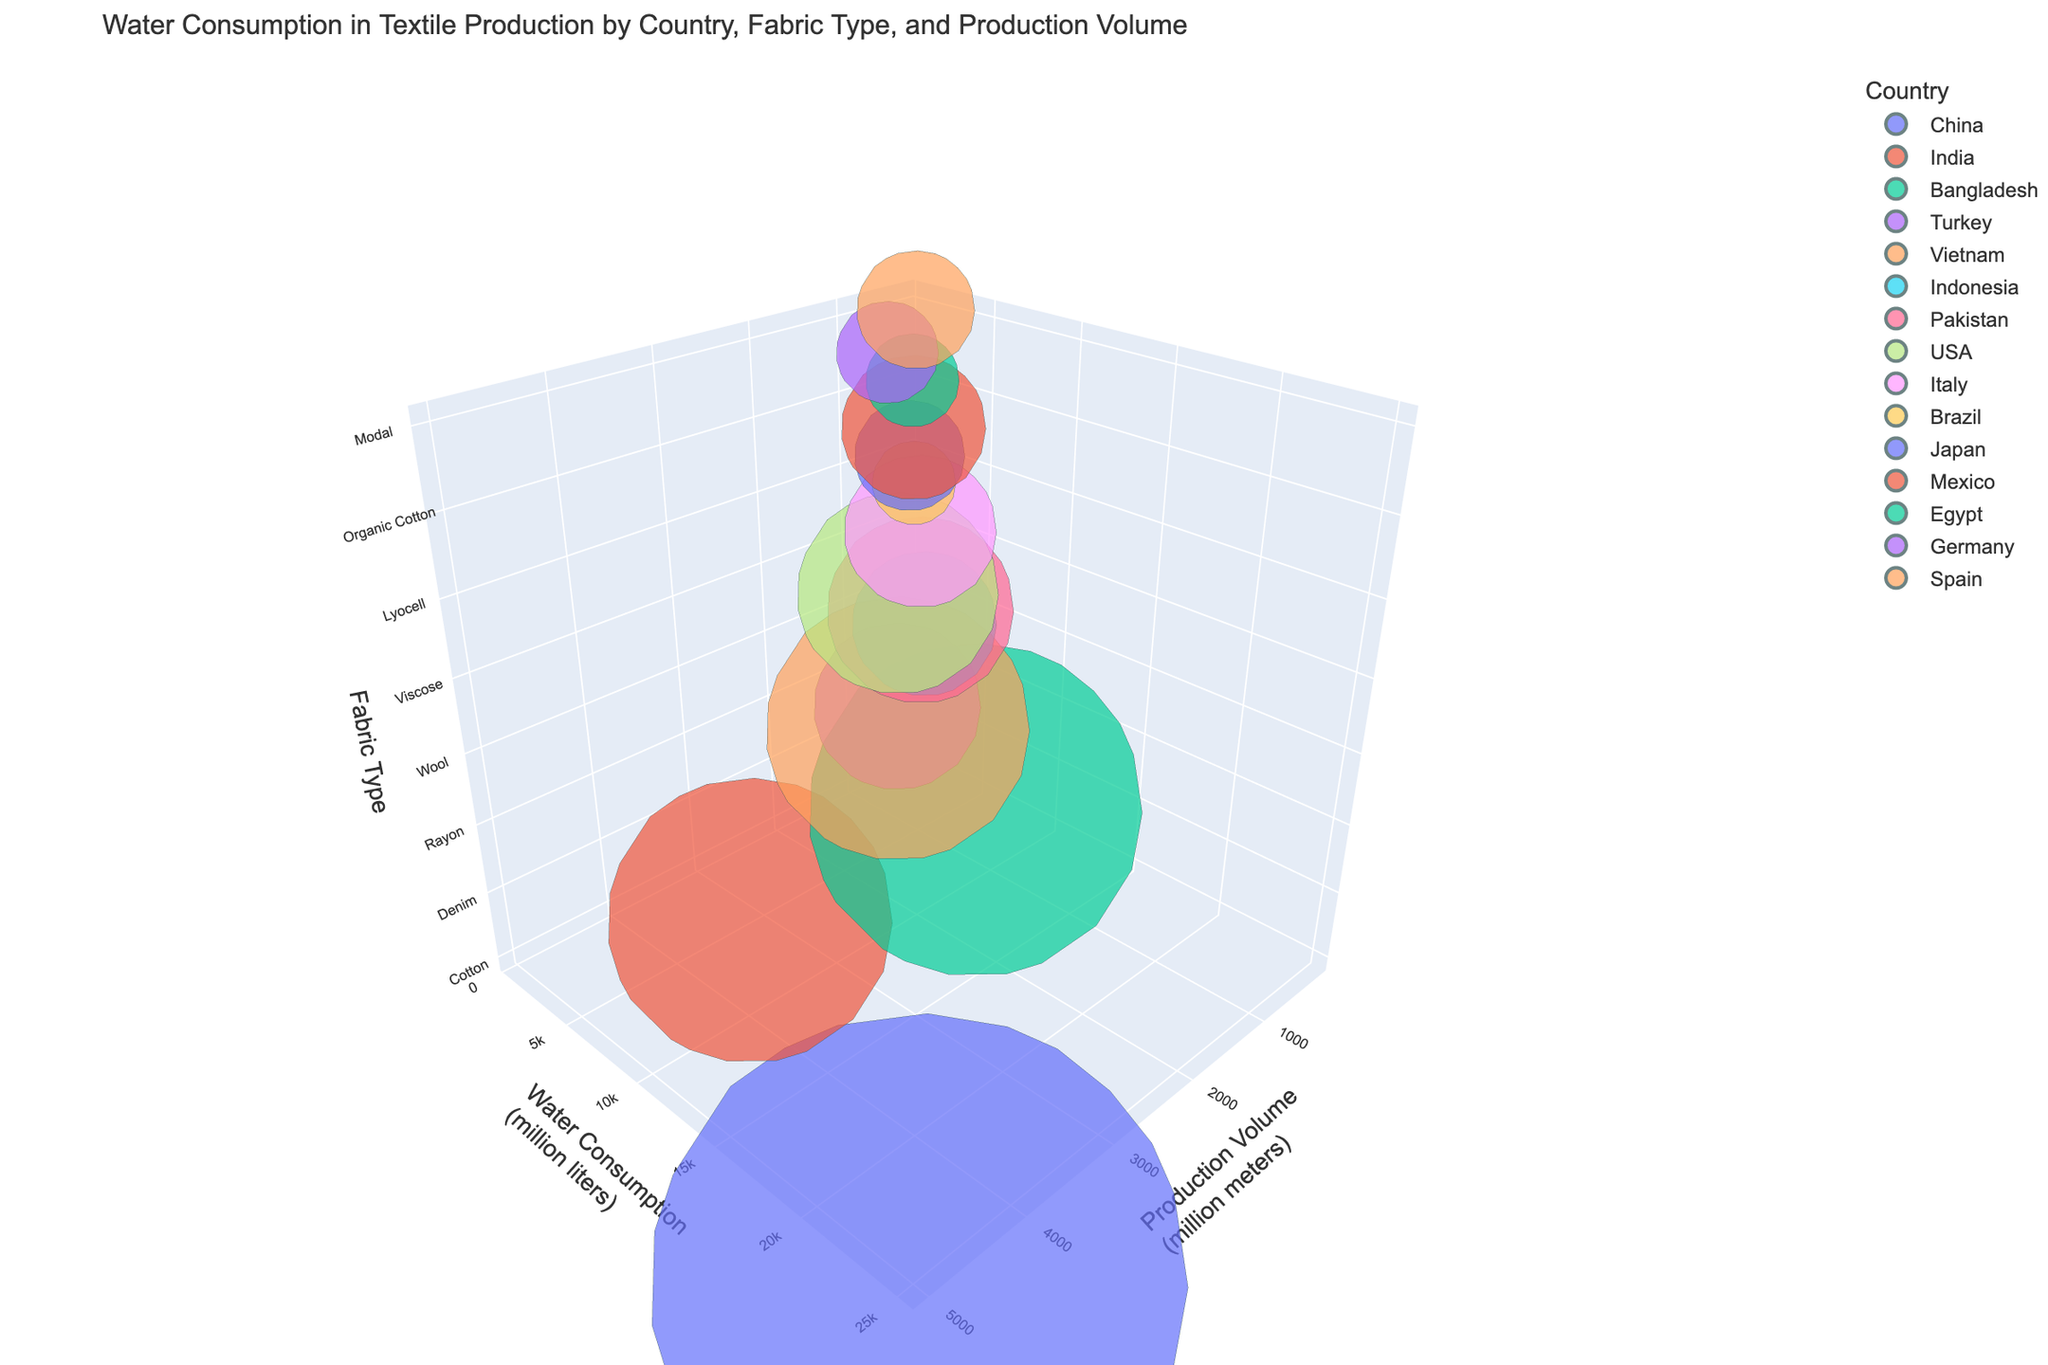What is the title of the figure? The title is generally found at the top of the figure. By looking at the top, you can see the main title describing the content of the figure. In this case, the title is "Water Consumption in Textile Production by Country, Fabric Type, and Production Volume".
Answer: Water Consumption in Textile Production by Country, Fabric Type, and Production Volume Which country has the highest production volume? The x-axis represents the production volume (in million meters). By looking at the farthest right data point on the x-axis, you can determine the country with the highest production volume. The point for China is farthest on the x-axis.
Answer: China How is color used in the plot? In the figure, colors represent different countries. Each unique color corresponds to a different country, making it easier to identify and compare data points.
Answer: Different countries Which fabric type consumes the least water? By examining the points on the y-axis (water consumption), the lowest point on this axis represents the lowest water consumption. The fabric type at this point (750 million liters) is associated with Egypt producing Organic Cotton.
Answer: Organic Cotton Between India and USA, which country consumes more water for textile production? Locate the data points for India and USA. Compare their positions along the y-axis (water consumption). India's point is higher on the y-axis compared to the USA's point.
Answer: India What is the relationship between production volume and water consumption for Bangladesh's denim production? Identify the data point for Bangladesh (Denim) and observe its position on the x-axis (production volume) and y-axis (water consumption). Bangladesh has a production volume of 1200 million meters and a water consumption of 9600 million liters.
Answer: Produces 1200 million meters and consumes 9600 million liters Which country produces the smallest volume of fabric? The x-axis represents production volume. The point located closest to the origin (smallest x value) indicates the smallest production volume. Brazil produces Hemp with a production volume of 200 million meters.
Answer: Brazil What's the average water consumption for Polyester and Recycled Polyester? Locate the data points for Polyester (India) and Recycled Polyester (Germany). The water consumption for Polyester is 7000 million liters, and for Recycled Polyester is 900 million liters. Calculate the average: (7000 + 900) / 2 = 3950 million liters.
Answer: 3950 million liters Which country produces wool? Find the data point labeled with the fabric type "Wool". The hover or label corresponding to this data point shows "Pakistan".
Answer: Pakistan What unique feature distinguishes this 3D plot from a 2D plot? Unlike 2D plots, this 3D plot includes three axes (x, y, and z), allowing visualization of three variables simultaneously. The z-axis represents Fabric Type, adding an extra dimension to the analysis.
Answer: 3 axes with z-axis as Fabric Type 